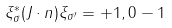Convert formula to latex. <formula><loc_0><loc_0><loc_500><loc_500>\xi _ { \sigma } ^ { * } ( J \cdot n ) \xi _ { \sigma ^ { \prime } } = + 1 , 0 - 1</formula> 